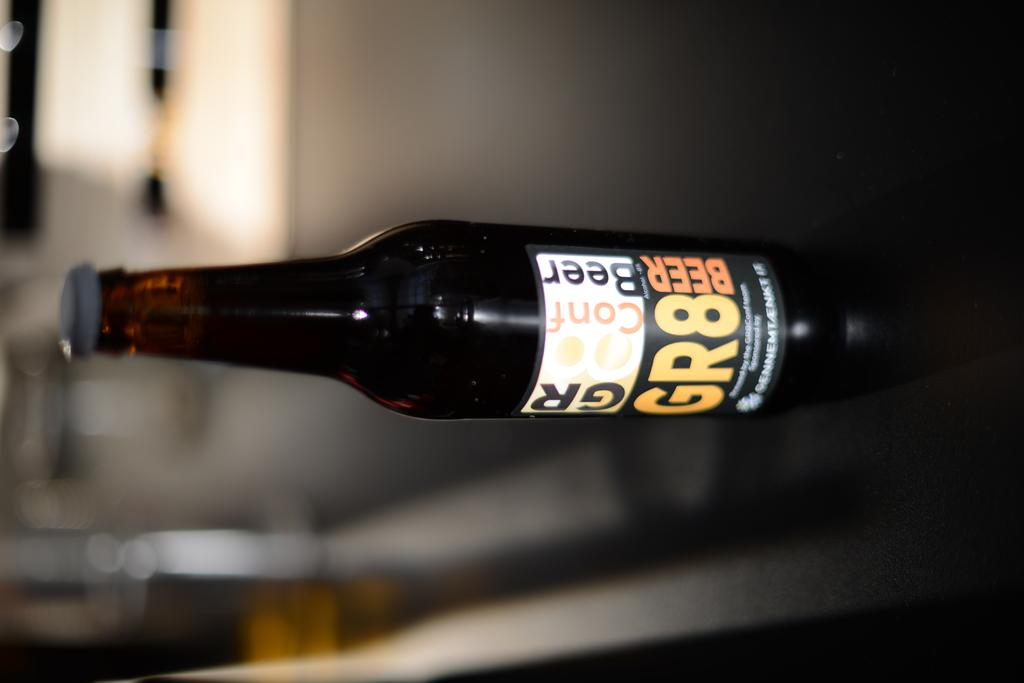Provide a one-sentence caption for the provided image. A bottle of beer says that it is GR8. 